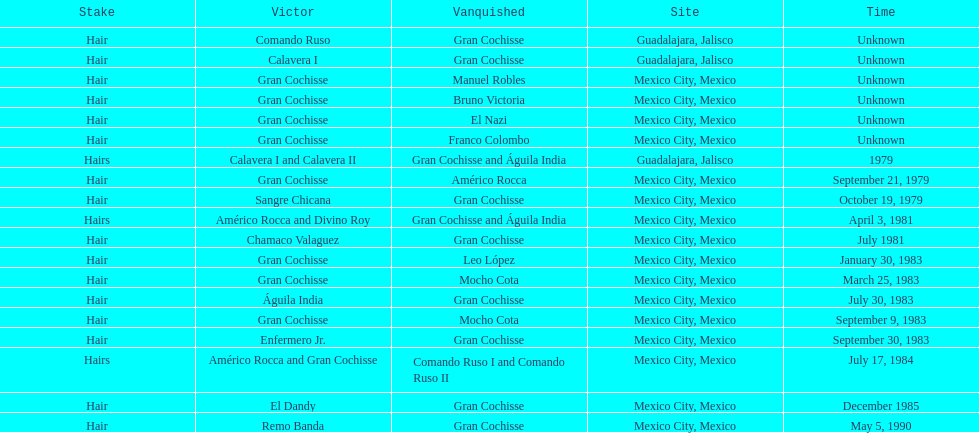How many games more than chamaco valaguez did sangre chicana win? 0. 